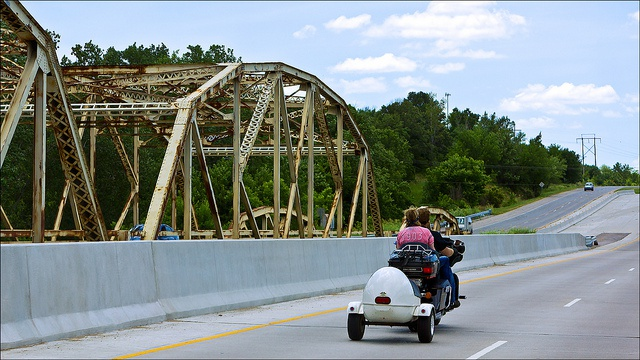Describe the objects in this image and their specific colors. I can see motorcycle in black, lavender, darkgray, and gray tones, people in black, olive, darkgray, and gray tones, people in black, violet, and brown tones, car in black, blue, tan, and navy tones, and car in black, gray, darkgray, and teal tones in this image. 